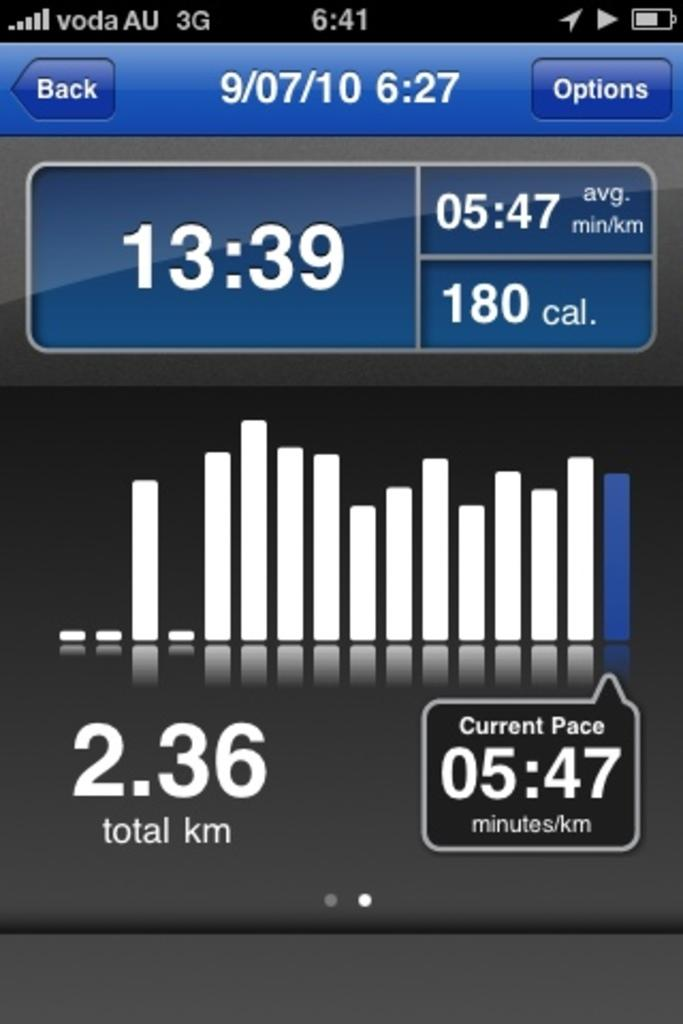<image>
Give a short and clear explanation of the subsequent image. A phone screen shows the current pace as 5:47 minutes/km 